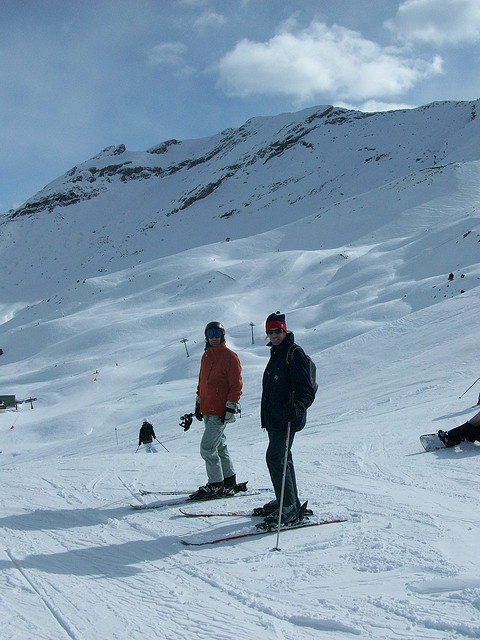Describe the objects in this image and their specific colors. I can see people in gray, black, darkgray, and lightblue tones, people in gray, black, maroon, and purple tones, skis in gray and black tones, people in gray, black, and blue tones, and skis in gray and black tones in this image. 